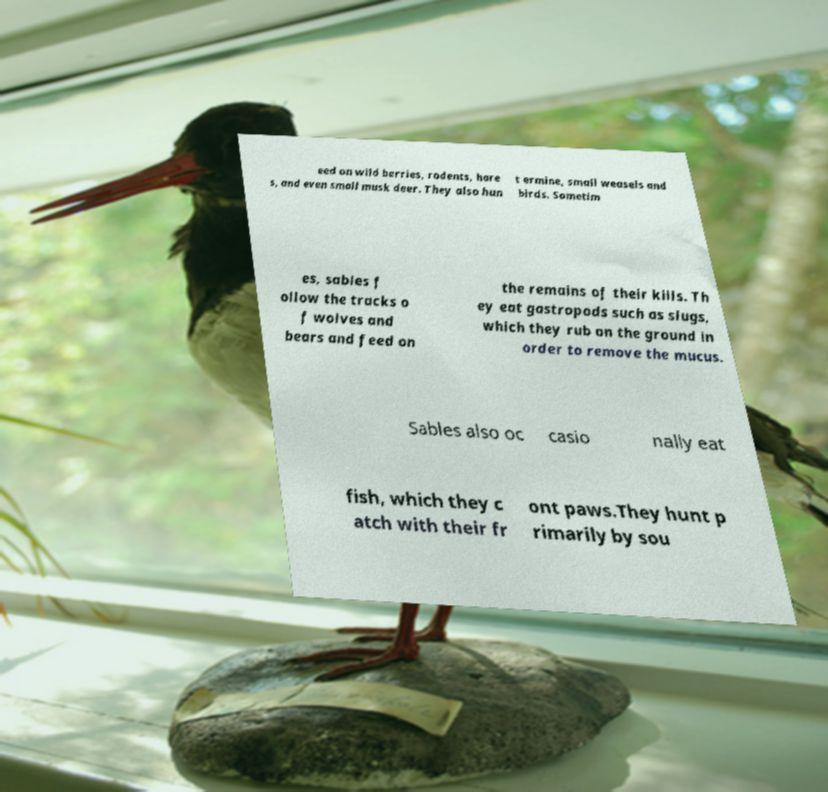Please identify and transcribe the text found in this image. eed on wild berries, rodents, hare s, and even small musk deer. They also hun t ermine, small weasels and birds. Sometim es, sables f ollow the tracks o f wolves and bears and feed on the remains of their kills. Th ey eat gastropods such as slugs, which they rub on the ground in order to remove the mucus. Sables also oc casio nally eat fish, which they c atch with their fr ont paws.They hunt p rimarily by sou 